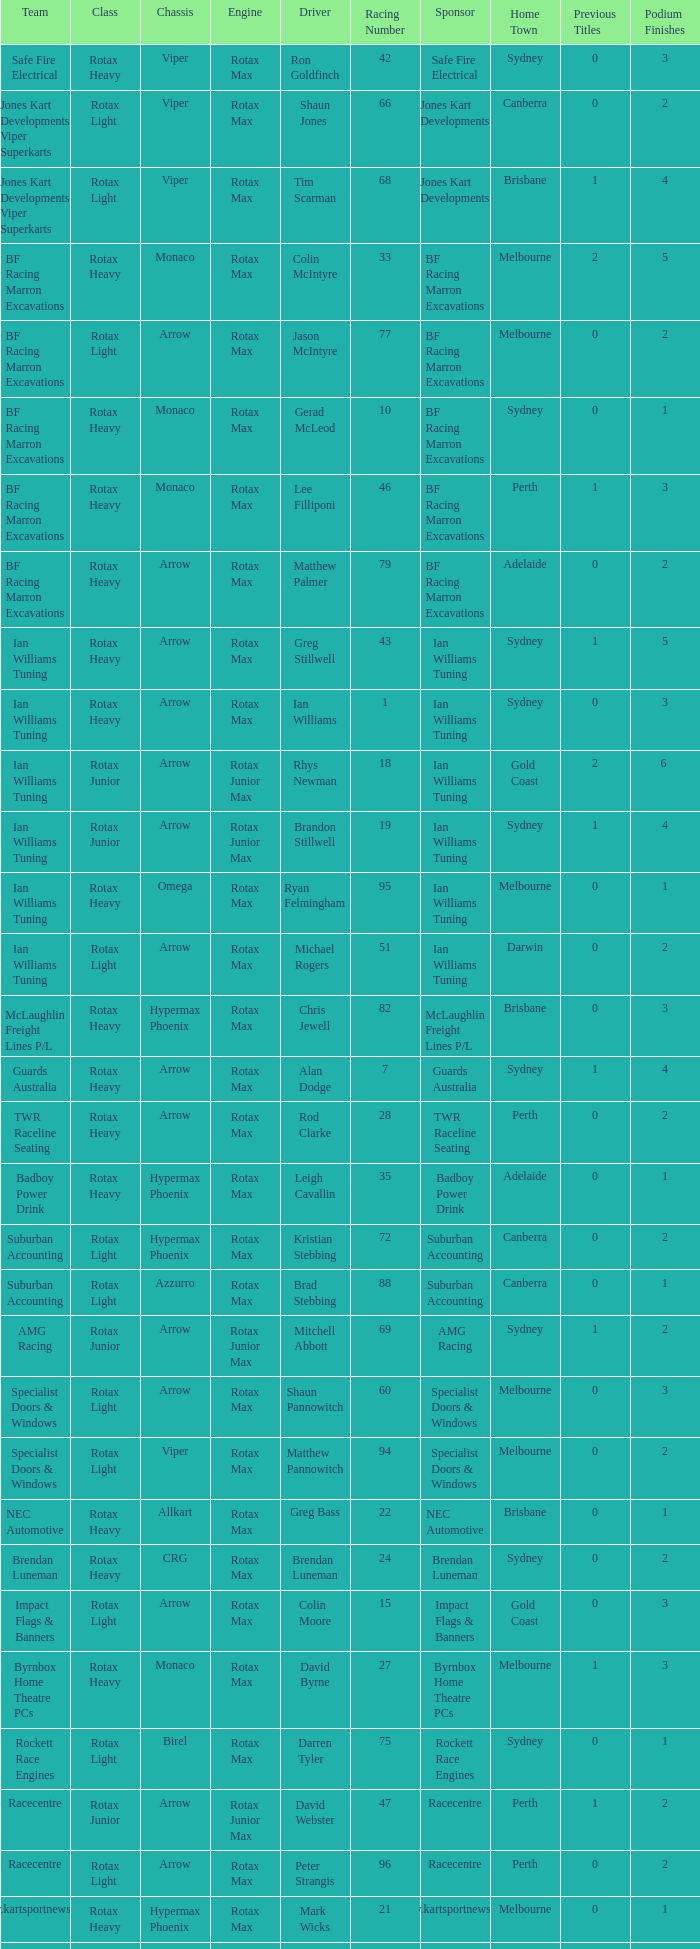Which team does Colin Moore drive for? Impact Flags & Banners. 